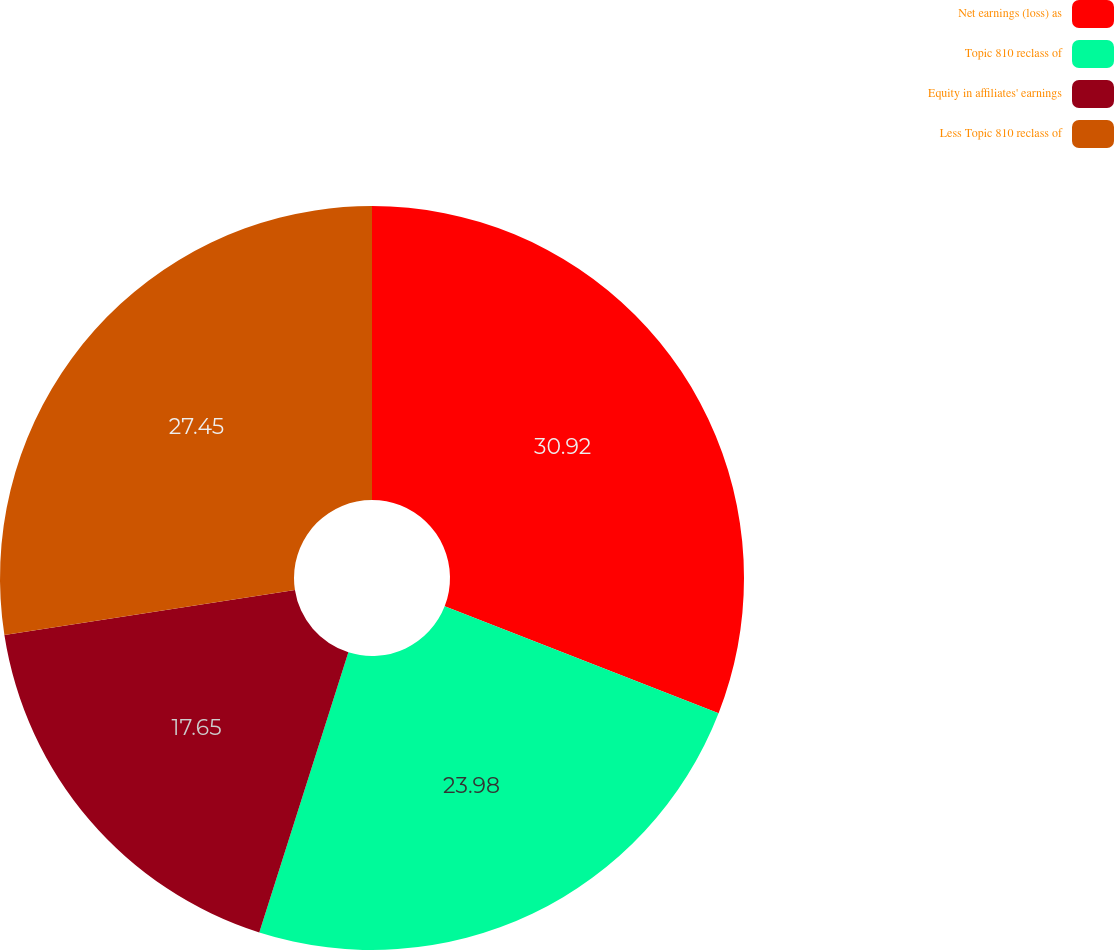Convert chart to OTSL. <chart><loc_0><loc_0><loc_500><loc_500><pie_chart><fcel>Net earnings (loss) as<fcel>Topic 810 reclass of<fcel>Equity in affiliates' earnings<fcel>Less Topic 810 reclass of<nl><fcel>30.92%<fcel>23.98%<fcel>17.65%<fcel>27.45%<nl></chart> 